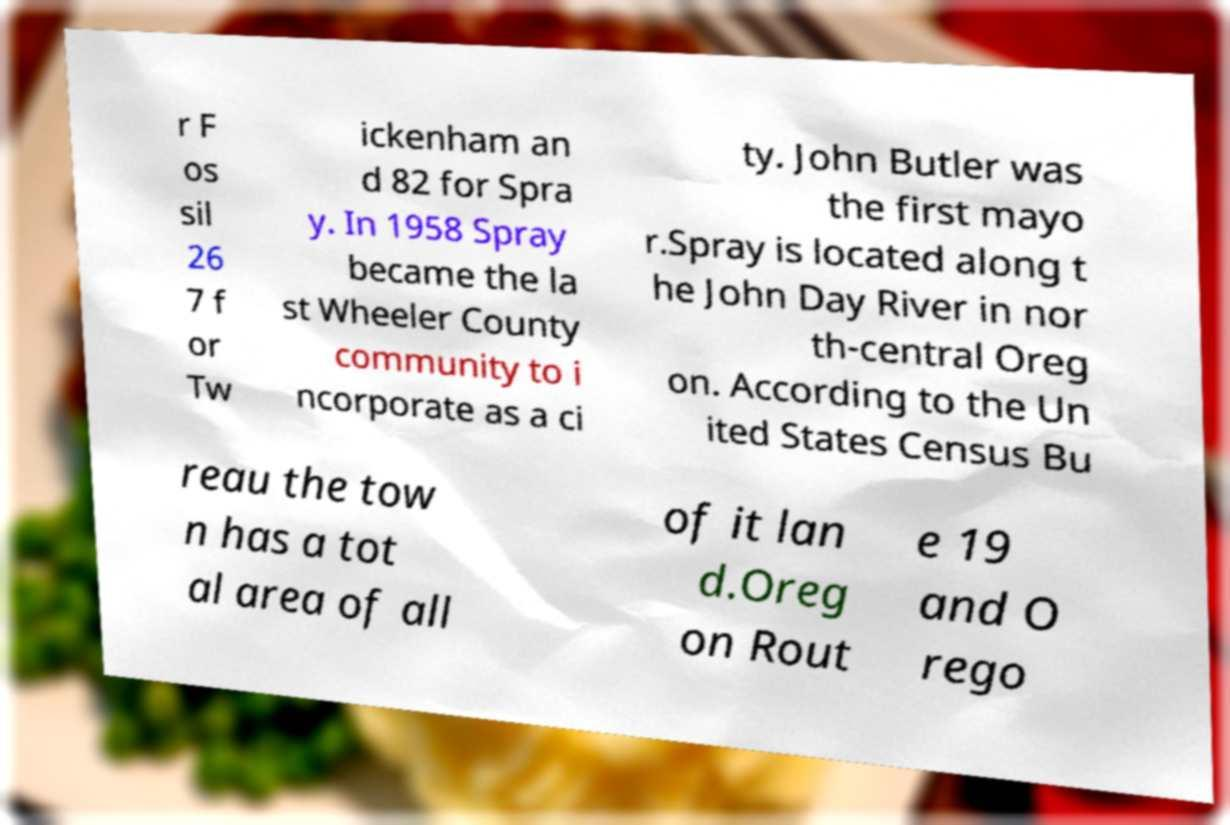What messages or text are displayed in this image? I need them in a readable, typed format. r F os sil 26 7 f or Tw ickenham an d 82 for Spra y. In 1958 Spray became the la st Wheeler County community to i ncorporate as a ci ty. John Butler was the first mayo r.Spray is located along t he John Day River in nor th-central Oreg on. According to the Un ited States Census Bu reau the tow n has a tot al area of all of it lan d.Oreg on Rout e 19 and O rego 